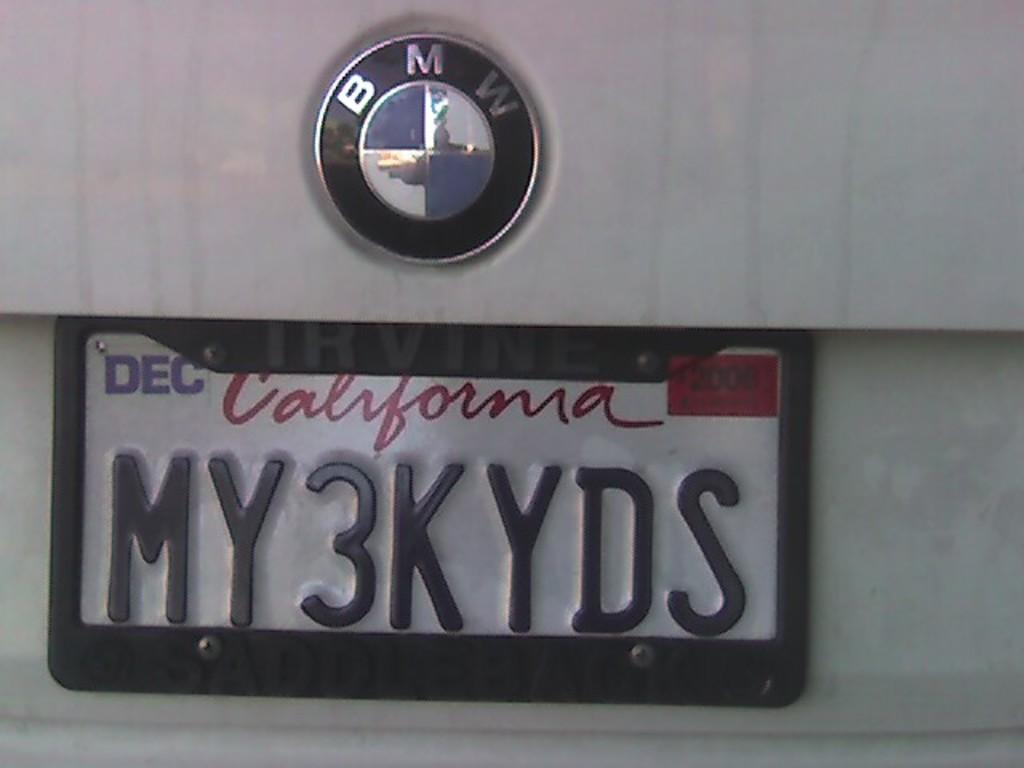Provide a one-sentence caption for the provided image. A California license place for a BMW says my3kyds. 